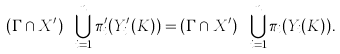Convert formula to latex. <formula><loc_0><loc_0><loc_500><loc_500>( \Gamma \cap X ^ { \prime } ) \ \bigcup _ { i = 1 } ^ { n } \pi _ { i } ^ { \prime } ( Y _ { i } ^ { \prime } ( K ) ) = ( \Gamma \cap X ^ { \prime } ) \ \bigcup _ { i = 1 } ^ { n } \pi _ { i } ( Y _ { i } ( K ) ) .</formula> 